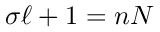Convert formula to latex. <formula><loc_0><loc_0><loc_500><loc_500>\sigma \ell + 1 = n N</formula> 